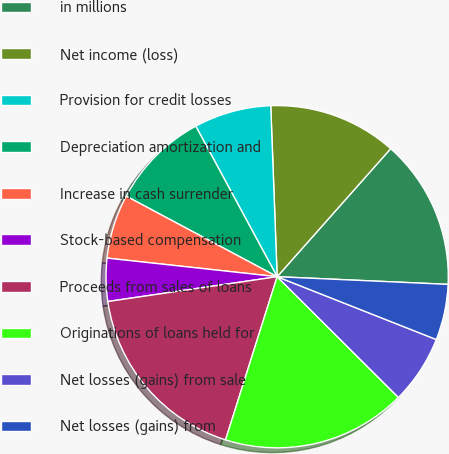Convert chart to OTSL. <chart><loc_0><loc_0><loc_500><loc_500><pie_chart><fcel>in millions<fcel>Net income (loss)<fcel>Provision for credit losses<fcel>Depreciation amortization and<fcel>Increase in cash surrender<fcel>Stock-based compensation<fcel>Proceeds from sales of loans<fcel>Originations of loans held for<fcel>Net losses (gains) from sale<fcel>Net losses (gains) from<nl><fcel>14.17%<fcel>12.14%<fcel>7.29%<fcel>9.31%<fcel>6.07%<fcel>4.05%<fcel>17.81%<fcel>17.41%<fcel>6.48%<fcel>5.27%<nl></chart> 